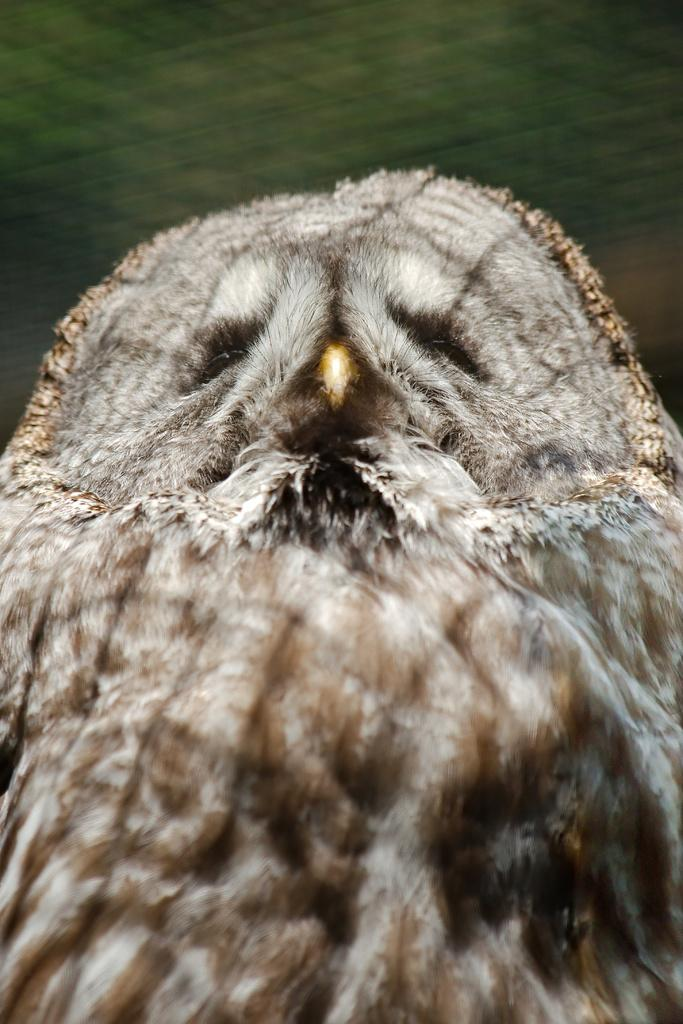What animal is the main subject of the image? There is an owl in the image. Can you describe the color of the owl? The owl is in brown and ash color. How would you describe the background of the image? The background of the image is blurred. Can you see any twigs or cobwebs in the image? There is no mention of twigs or cobwebs in the image, so we cannot determine their presence. 